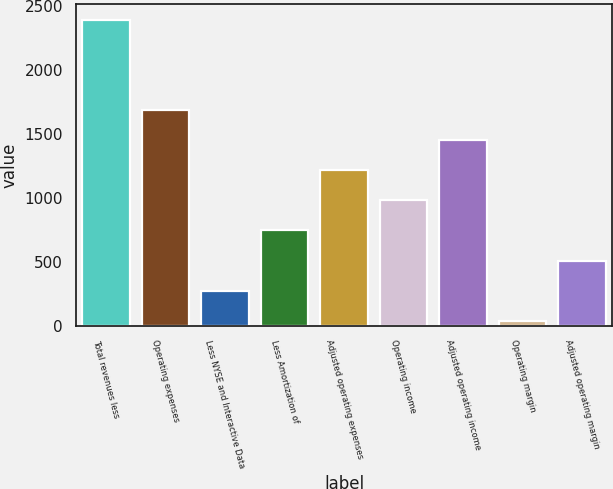Convert chart. <chart><loc_0><loc_0><loc_500><loc_500><bar_chart><fcel>Total revenues less<fcel>Operating expenses<fcel>Less NYSE and Interactive Data<fcel>Less Amortization of<fcel>Adjusted operating expenses<fcel>Operating income<fcel>Adjusted operating income<fcel>Operating margin<fcel>Adjusted operating margin<nl><fcel>2397<fcel>1689.6<fcel>274.8<fcel>746.4<fcel>1218<fcel>982.2<fcel>1453.8<fcel>39<fcel>510.6<nl></chart> 